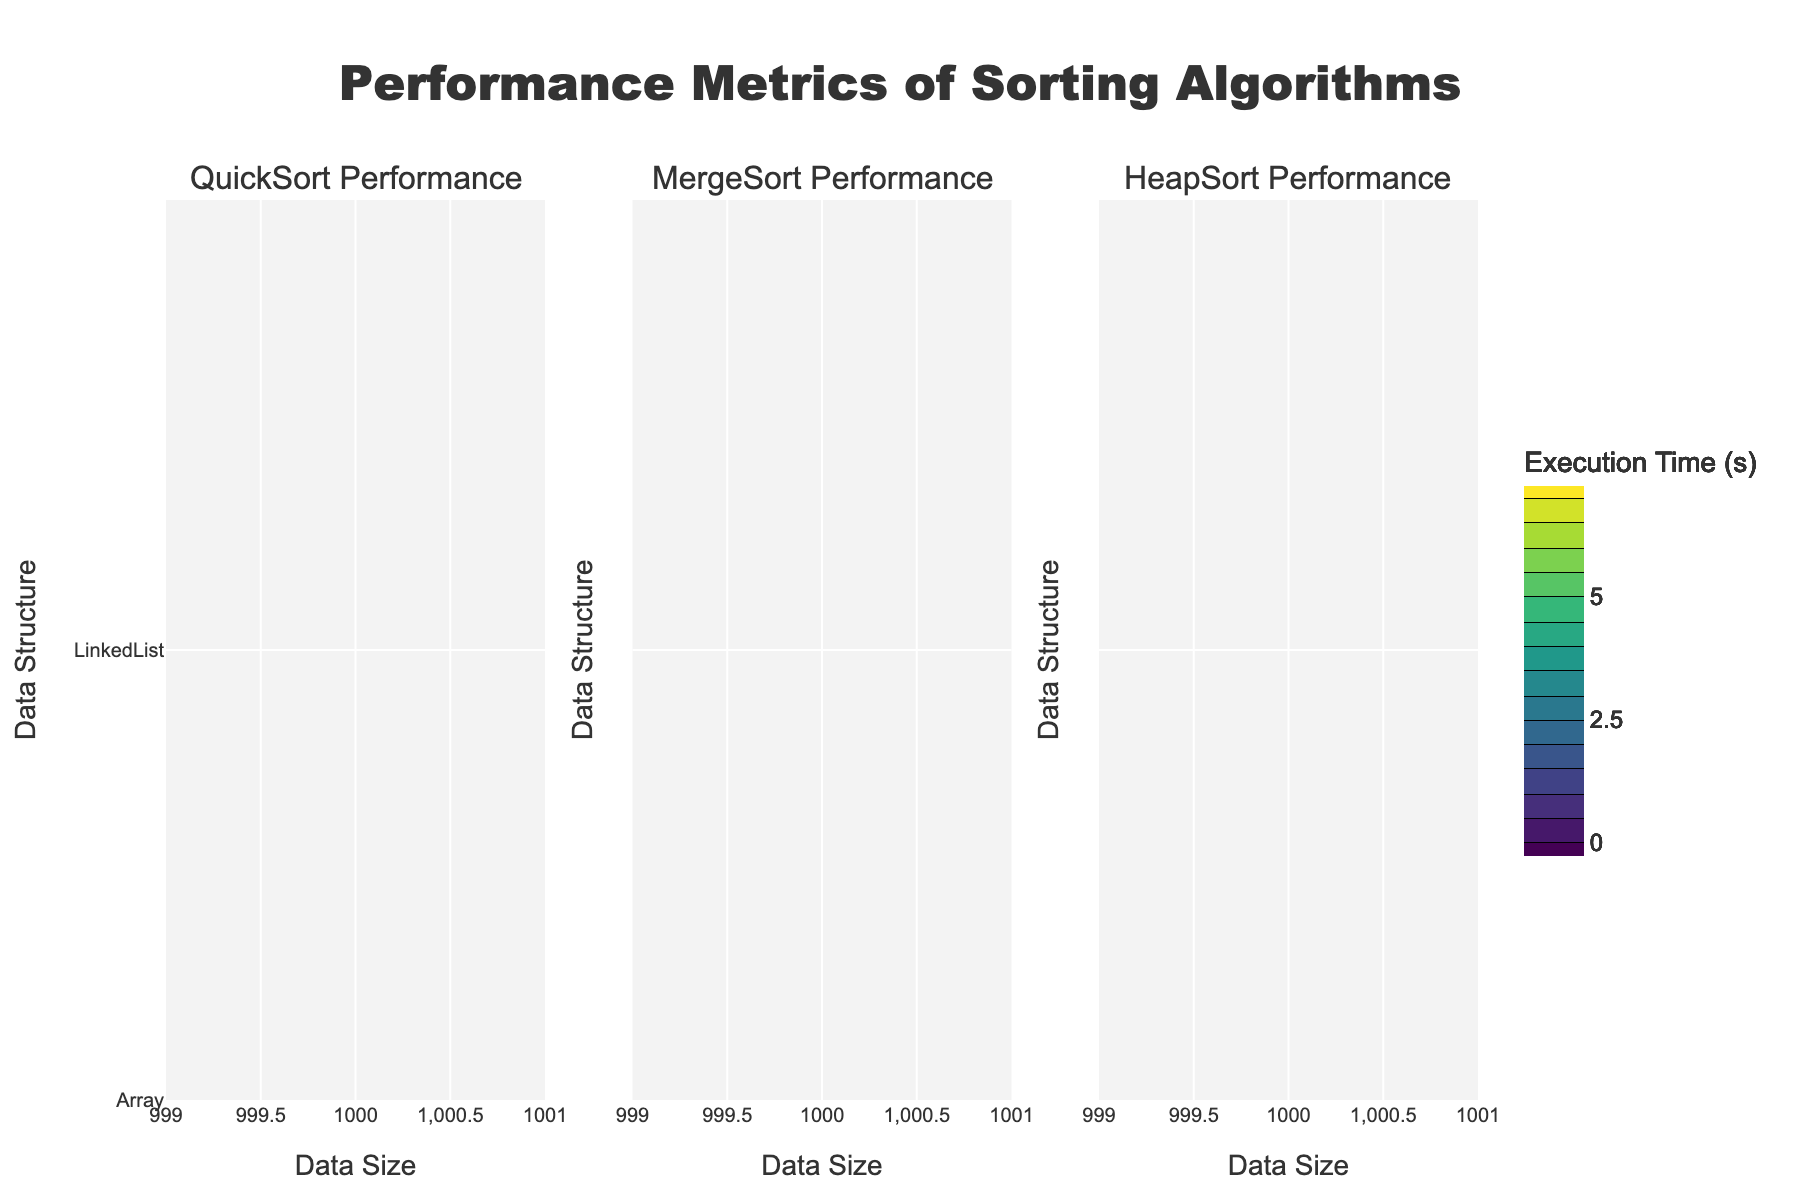What is the title of the figure? The title is located at the top of the figure. It reads 'Performance Metrics of Sorting Algorithms'.
Answer: Performance Metrics of Sorting Algorithms What are the data structures compared in the figure? The data structures are noted on the y-axis, represented distinctly. They are "Array" and "LinkedList".
Answer: Array, LinkedList Which sorting algorithm seems to perform the fastest for an array when the data size is 5000? Observe the color gradient for the array data structure at 5000 data size on the respective subplot. QuickSort is the fastest since it has a lighter hue compared to MergeSort and HeapSort.
Answer: QuickSort How does the execution time of MergeSort for a linked list change as the data size increases from 1000 to 10000? Look at the MergeSort subplot and track the gradient from 1000 to 10000 on the y-axis for "LinkedList". The color transitions from a lighter shade to a darker shade, indicating that the execution time increases.
Answer: It increases Which algorithm has the greatest execution time for linked lists when the data size is 10000? Examine the contours for the linked list at data size 10000 across all subplots. HeapSort exhibits the darkest shade, indicating the highest execution time.
Answer: HeapSort Between QuickSort and HeapSort, which one is more efficient for arrays of size 10000? Compare the contour colors for data size 10000 in the QuickSort and HeapSort subplots for "Array". QuickSort has a lighter color indicating it is more efficient.
Answer: QuickSort For the linked list, how does the performance of QuickSort at data size 5000 compare to MergeSort at the same data size? Check the colors corresponding to data size 5000 for "LinkedList" in both QuickSort and MergeSort subplots. QuickSort has a darker hue showing it takes longer than MergeSort.
Answer: MergeSort performs better If the data size is doubled from 5000 to 10000, how does the execution time of HeapSort change for arrays? Analyze the HeapSort subplot for "Array" and track the color change from size 5000 to 10000. The color darkens, implying the execution time roughly doubles increasing significantly.
Answer: It increases significantly Which data structure shows a more significant difference in performance between QuickSort and HeapSort? Compare the color differences between QuickSort and HeapSort subplots for both "Array" and "LinkedList". The discrepancy is more pronounced in "LinkedList" observed by a stark contrast in colors.
Answer: LinkedList 